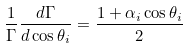Convert formula to latex. <formula><loc_0><loc_0><loc_500><loc_500>\frac { 1 } { \Gamma } \frac { d \Gamma } { d \cos \theta _ { i } } = \frac { 1 + \alpha _ { i } \cos \theta _ { i } } { 2 }</formula> 